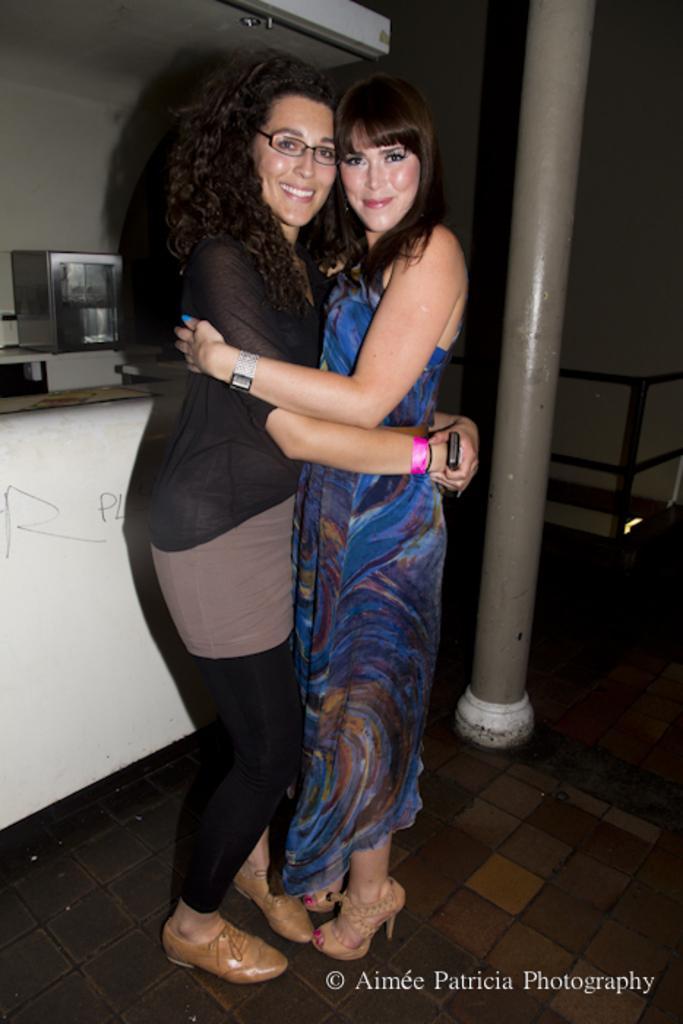Describe this image in one or two sentences. In this image, there are two women standing on the floor, hugging each other and smiling. On the right side of the image, I can see a pole. On the left side of the image, there is an object. At the bottom of the image, I can see the watermark. 